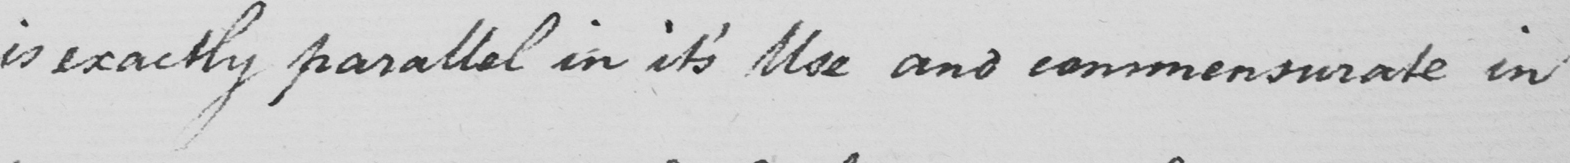What text is written in this handwritten line? is exactly parallel in it ' s Use and commensurate in 